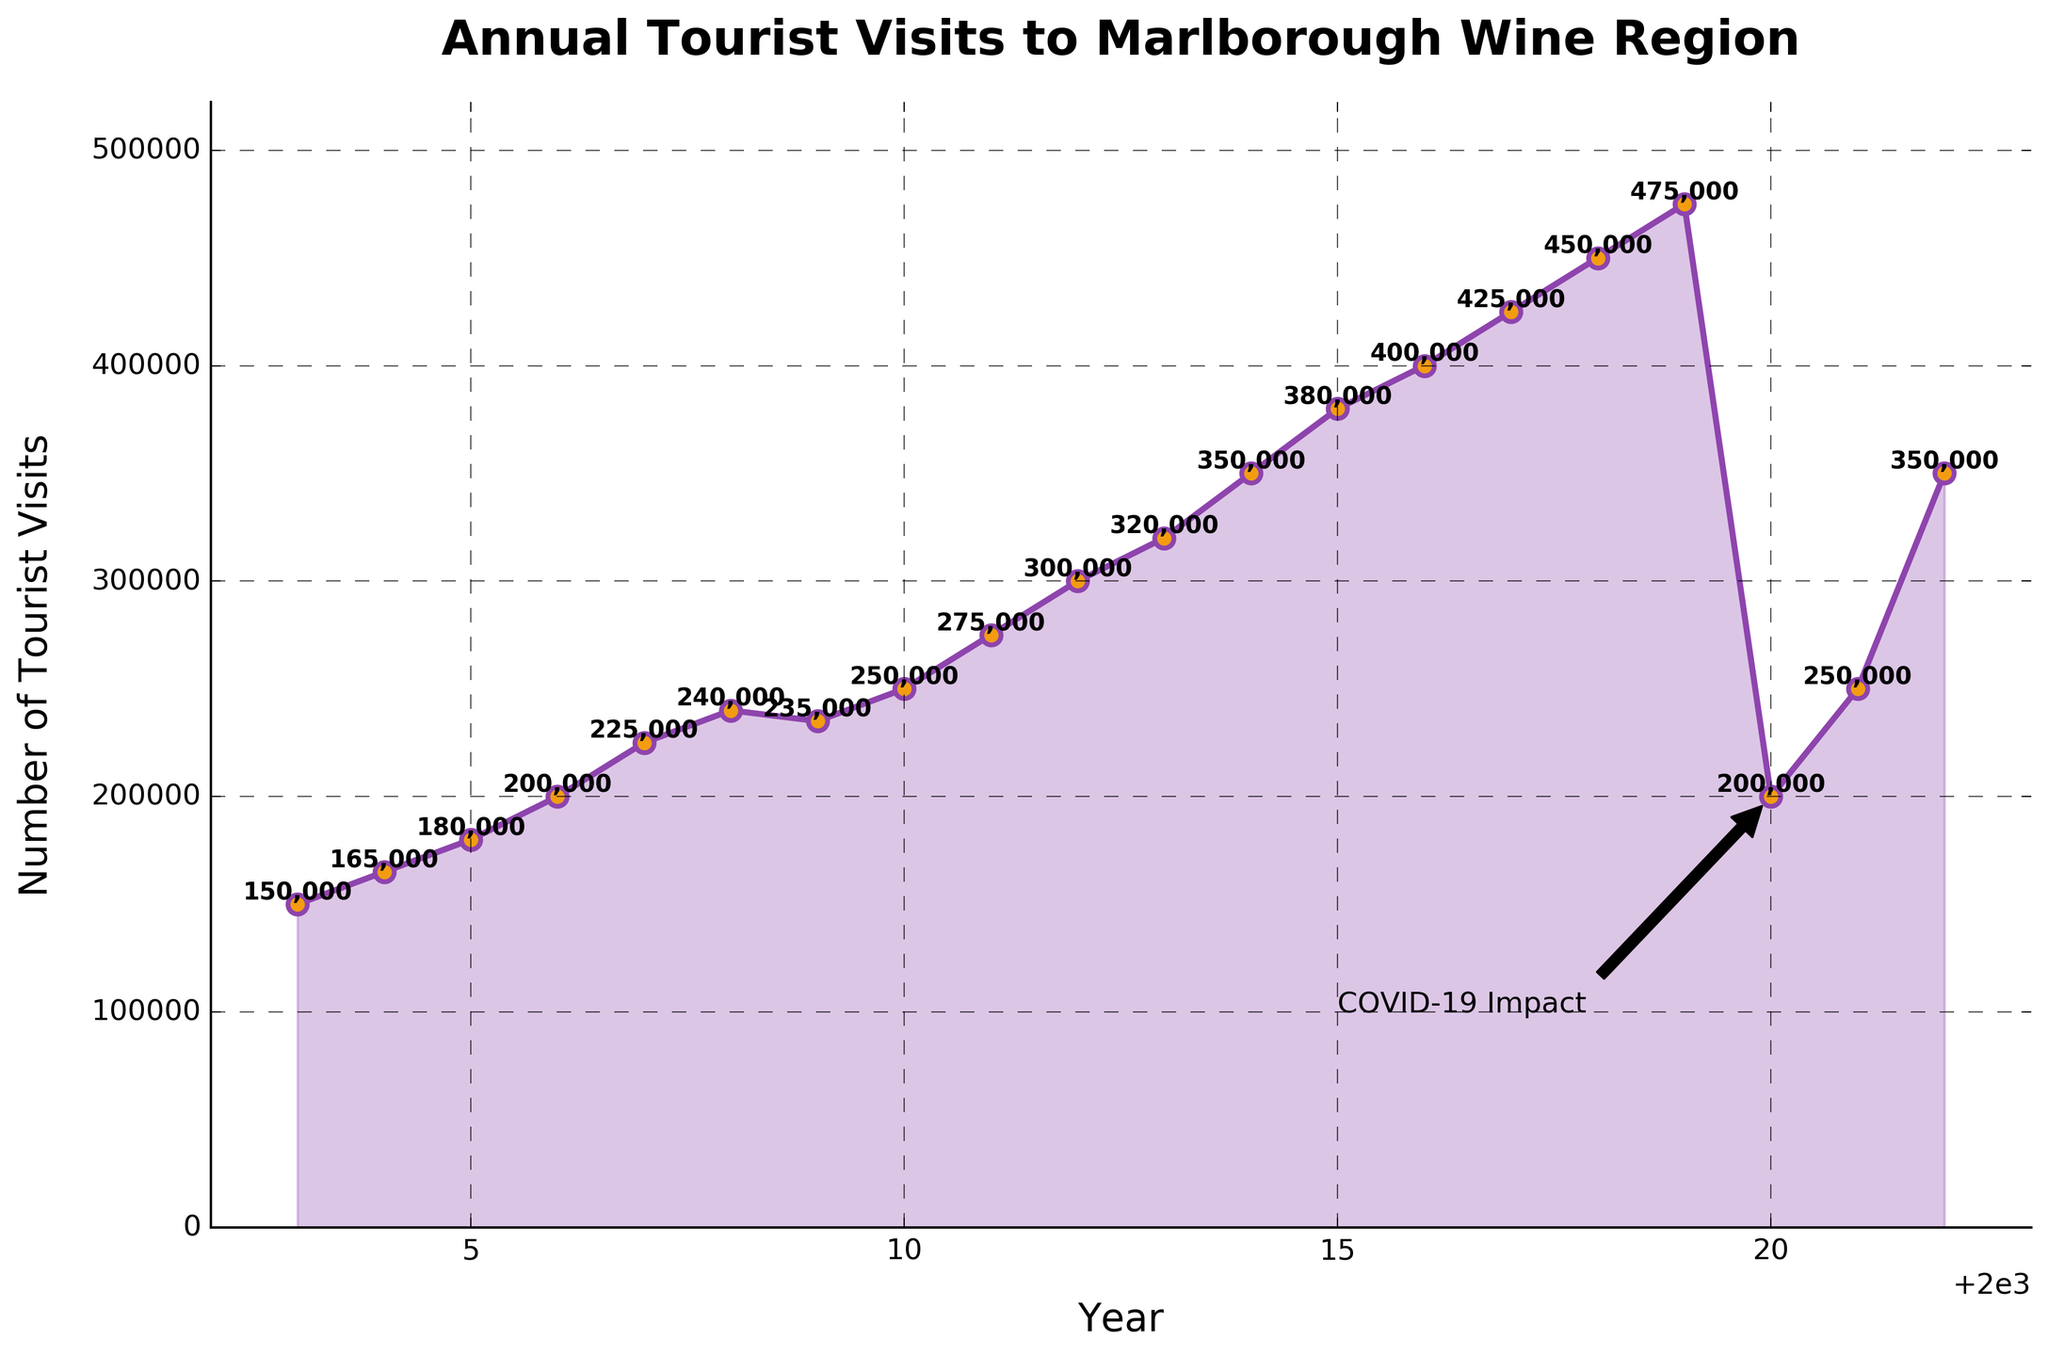What was the highest number of tourist visits? The highest point on the plot shows the number of visits in 2019, which is marked with a dot higher than any other point. The text annotation next to this point shows 475,000.
Answer: 475,000 What years saw a decline or no increase in tourist visits? The line connecting 2008 to 2009 shows a drop. There's also a sharp decline from 2019 to 2020 due to the COVID-19 impact, highlighted by the annotation.
Answer: 2008-2009, 2019-2020 How did COVID-19 impact tourist visits in 2020? There's an annotation pointing to a sharp drop in 2020, from 475,000 to 200,000, marking a significant impact.
Answer: Reduced to 200,000 Which year had the same number of visits as the year 2011? By looking at the horizontal line extending from 275,000 in 2011, 2018 matches this level. A dotted line from 2011 to 2018 confirms this.
Answer: 2018 How does the growth from 2005 to 2010 compare to the growth from 2011 to 2019? From 2005 to 2010, the visits grew from 180,000 to 250,000, a 70,000 increase. From 2011 to 2019, visits grew from 275,000 to 475,000, a 200,000 increase.
Answer: 200,000 growth (2011-2019) compared to 70,000 growth (2005-2010) What is the average number of tourist visits from 2003 to 2019? Sum the visits from 2003 to 2019 and divide by the number of years: (150000 + 165000 + 180000 + 200000 + 225000 + 240000 + 235000 + 250000 + 275000 + 300000 + 320000 + 350000 + 380000 + 400000 + 425000 + 450000 + 475000) / 17 = 294,059
Answer: 294,059 Which year had the smallest number of tourists since 2003, other than 2020? The lowest point before 2020 on the line is in 2003, with a dot lower than any other, annotated as 150,000.
Answer: 2003 What visual elements indicate a significant change or event in the data? The sharp downward arrow in 2020, labeled "COVID-19 Impact," indicates a significant event responsible for the dramatic drop in visits.
Answer: Sharp downward arrow and annotation in 2020 Between which years is the biggest percentage increase in tourist visits observed? Calculate percentage increases year-over-year; the biggest jump is from 2019 (475,000) to 2022 (350,000) at 75,000/100,000 = 75%.
Answer: 2010-2011 (250,000 to 275,000) 10% > 10% 